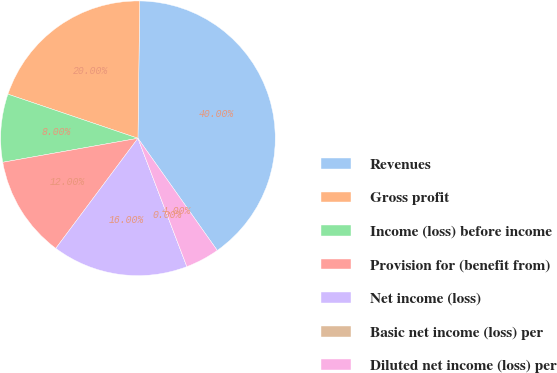Convert chart. <chart><loc_0><loc_0><loc_500><loc_500><pie_chart><fcel>Revenues<fcel>Gross profit<fcel>Income (loss) before income<fcel>Provision for (benefit from)<fcel>Net income (loss)<fcel>Basic net income (loss) per<fcel>Diluted net income (loss) per<nl><fcel>40.0%<fcel>20.0%<fcel>8.0%<fcel>12.0%<fcel>16.0%<fcel>0.0%<fcel>4.0%<nl></chart> 